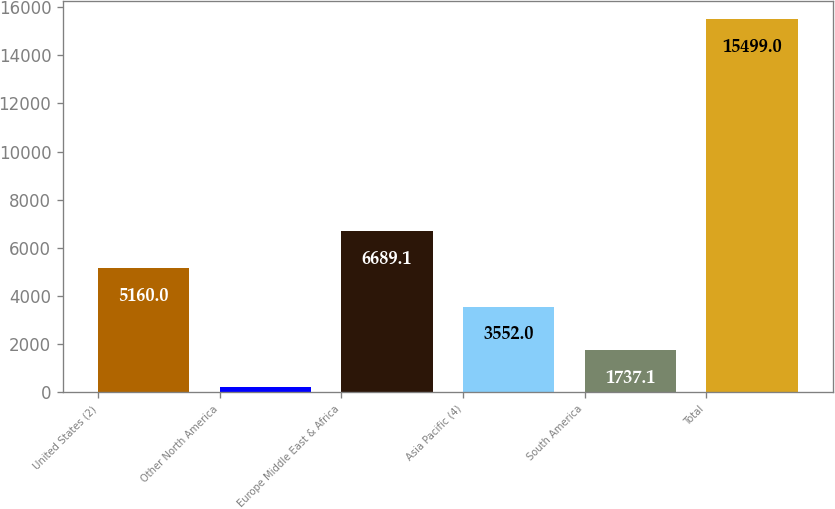Convert chart to OTSL. <chart><loc_0><loc_0><loc_500><loc_500><bar_chart><fcel>United States (2)<fcel>Other North America<fcel>Europe Middle East & Africa<fcel>Asia Pacific (4)<fcel>South America<fcel>Total<nl><fcel>5160<fcel>208<fcel>6689.1<fcel>3552<fcel>1737.1<fcel>15499<nl></chart> 